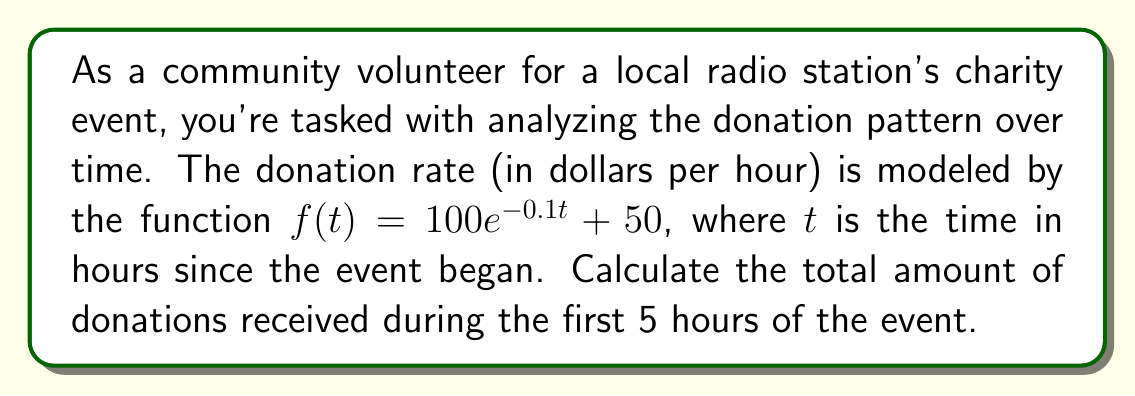What is the answer to this math problem? To find the total amount of donations over the 5-hour period, we need to calculate the area under the curve of the donation rate function. This can be done using definite integration.

1) The function representing the donation rate is:
   $f(t) = 100e^{-0.1t} + 50$

2) We need to integrate this function from $t=0$ to $t=5$:
   $$\int_0^5 (100e^{-0.1t} + 50) dt$$

3) Let's split this into two integrals:
   $$\int_0^5 100e^{-0.1t} dt + \int_0^5 50 dt$$

4) For the first integral, we use u-substitution:
   Let $u = -0.1t$, then $du = -0.1dt$ or $dt = -10du$
   When $t=0$, $u=0$; when $t=5$, $u=-0.5$

   $$-1000 \int_0^{-0.5} e^u du = -1000 [e^u]_0^{-0.5} = -1000(e^{-0.5} - 1)$$

5) The second integral is straightforward:
   $$50 \int_0^5 dt = 50[t]_0^5 = 250$$

6) Adding the results from steps 4 and 5:
   $$-1000(e^{-0.5} - 1) + 250 = 1000 - 1000e^{-0.5} + 250 = 1250 - 1000e^{-0.5}$$

7) Calculate the final value:
   $1250 - 1000 * 0.6065 = 643.50$

Therefore, the total amount of donations received during the first 5 hours is approximately $643.50.
Answer: $643.50 